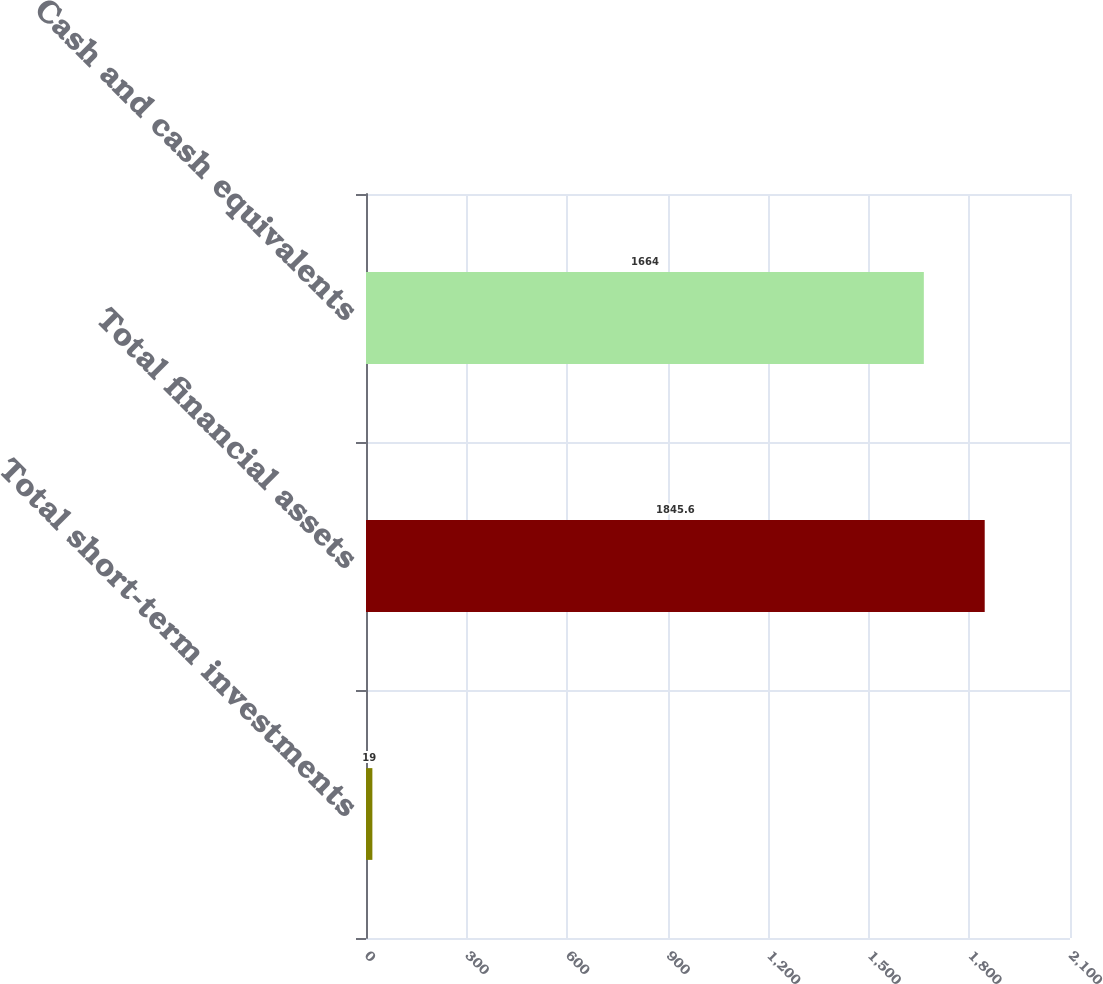Convert chart. <chart><loc_0><loc_0><loc_500><loc_500><bar_chart><fcel>Total short-term investments<fcel>Total financial assets<fcel>Cash and cash equivalents<nl><fcel>19<fcel>1845.6<fcel>1664<nl></chart> 